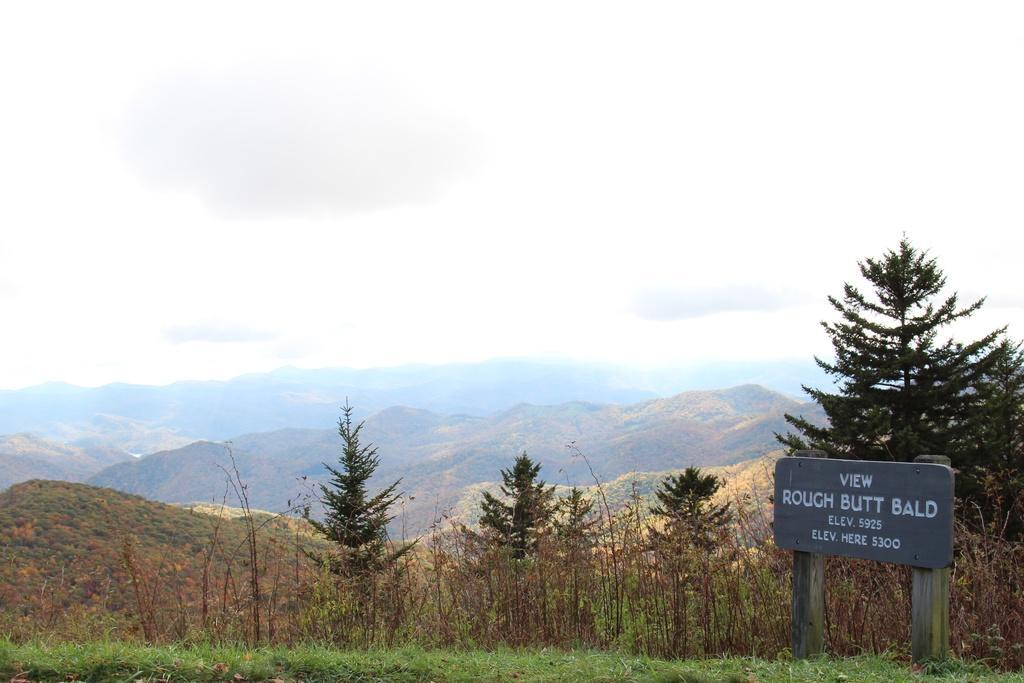How would you summarize this image in a sentence or two? In this image I can see there is a grass. And there is a wooden board with text. And at the back there is a tree and mountains. And at the top there is a sky. 